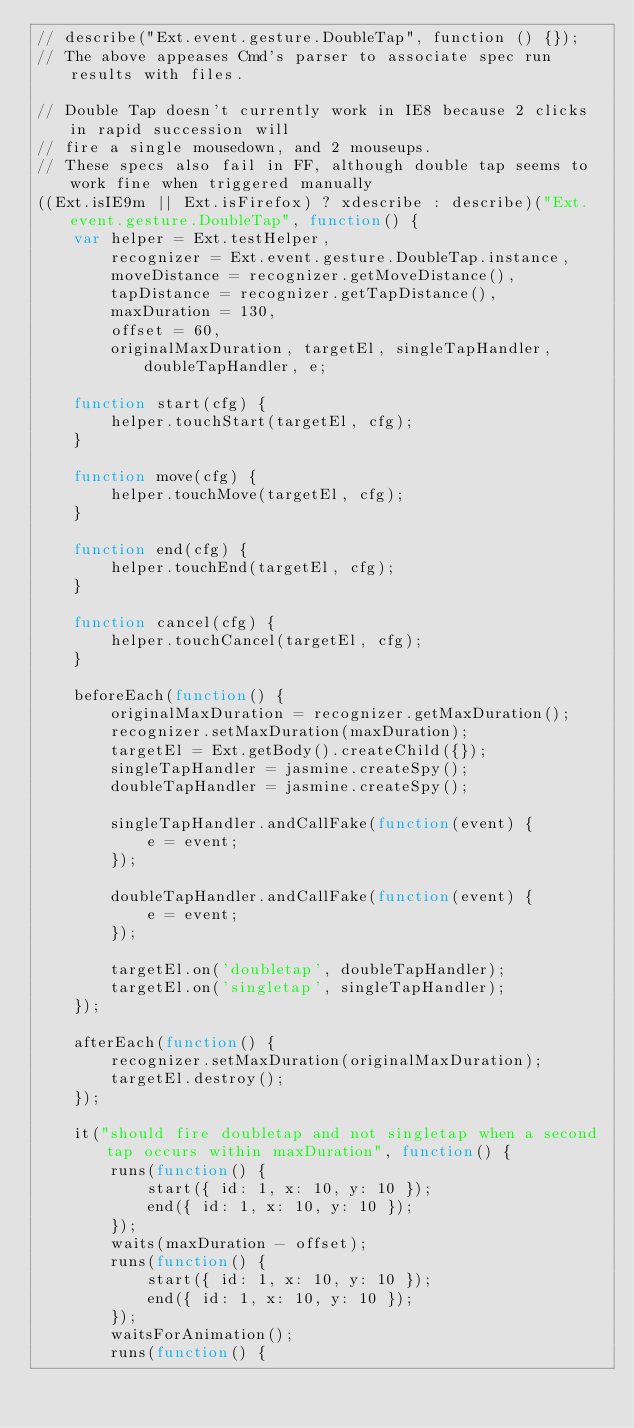Convert code to text. <code><loc_0><loc_0><loc_500><loc_500><_JavaScript_>// describe("Ext.event.gesture.DoubleTap", function () {});
// The above appeases Cmd's parser to associate spec run results with files.

// Double Tap doesn't currently work in IE8 because 2 clicks in rapid succession will
// fire a single mousedown, and 2 mouseups.
// These specs also fail in FF, although double tap seems to work fine when triggered manually
((Ext.isIE9m || Ext.isFirefox) ? xdescribe : describe)("Ext.event.gesture.DoubleTap", function() {
    var helper = Ext.testHelper,
        recognizer = Ext.event.gesture.DoubleTap.instance,
        moveDistance = recognizer.getMoveDistance(),
        tapDistance = recognizer.getTapDistance(),
        maxDuration = 130,
        offset = 60,
        originalMaxDuration, targetEl, singleTapHandler, doubleTapHandler, e;

    function start(cfg) {
        helper.touchStart(targetEl, cfg);
    }

    function move(cfg) {
        helper.touchMove(targetEl, cfg);
    }

    function end(cfg) {
        helper.touchEnd(targetEl, cfg);
    }

    function cancel(cfg) {
        helper.touchCancel(targetEl, cfg);
    }

    beforeEach(function() {
        originalMaxDuration = recognizer.getMaxDuration();
        recognizer.setMaxDuration(maxDuration);
        targetEl = Ext.getBody().createChild({});
        singleTapHandler = jasmine.createSpy();
        doubleTapHandler = jasmine.createSpy();

        singleTapHandler.andCallFake(function(event) {
            e = event;
        });

        doubleTapHandler.andCallFake(function(event) {
            e = event;
        });

        targetEl.on('doubletap', doubleTapHandler);
        targetEl.on('singletap', singleTapHandler);
    });

    afterEach(function() {
        recognizer.setMaxDuration(originalMaxDuration);
        targetEl.destroy();
    });

    it("should fire doubletap and not singletap when a second tap occurs within maxDuration", function() {
        runs(function() {
            start({ id: 1, x: 10, y: 10 });
            end({ id: 1, x: 10, y: 10 });
        });
        waits(maxDuration - offset);
        runs(function() {
            start({ id: 1, x: 10, y: 10 });
            end({ id: 1, x: 10, y: 10 });
        });
        waitsForAnimation();
        runs(function() {</code> 